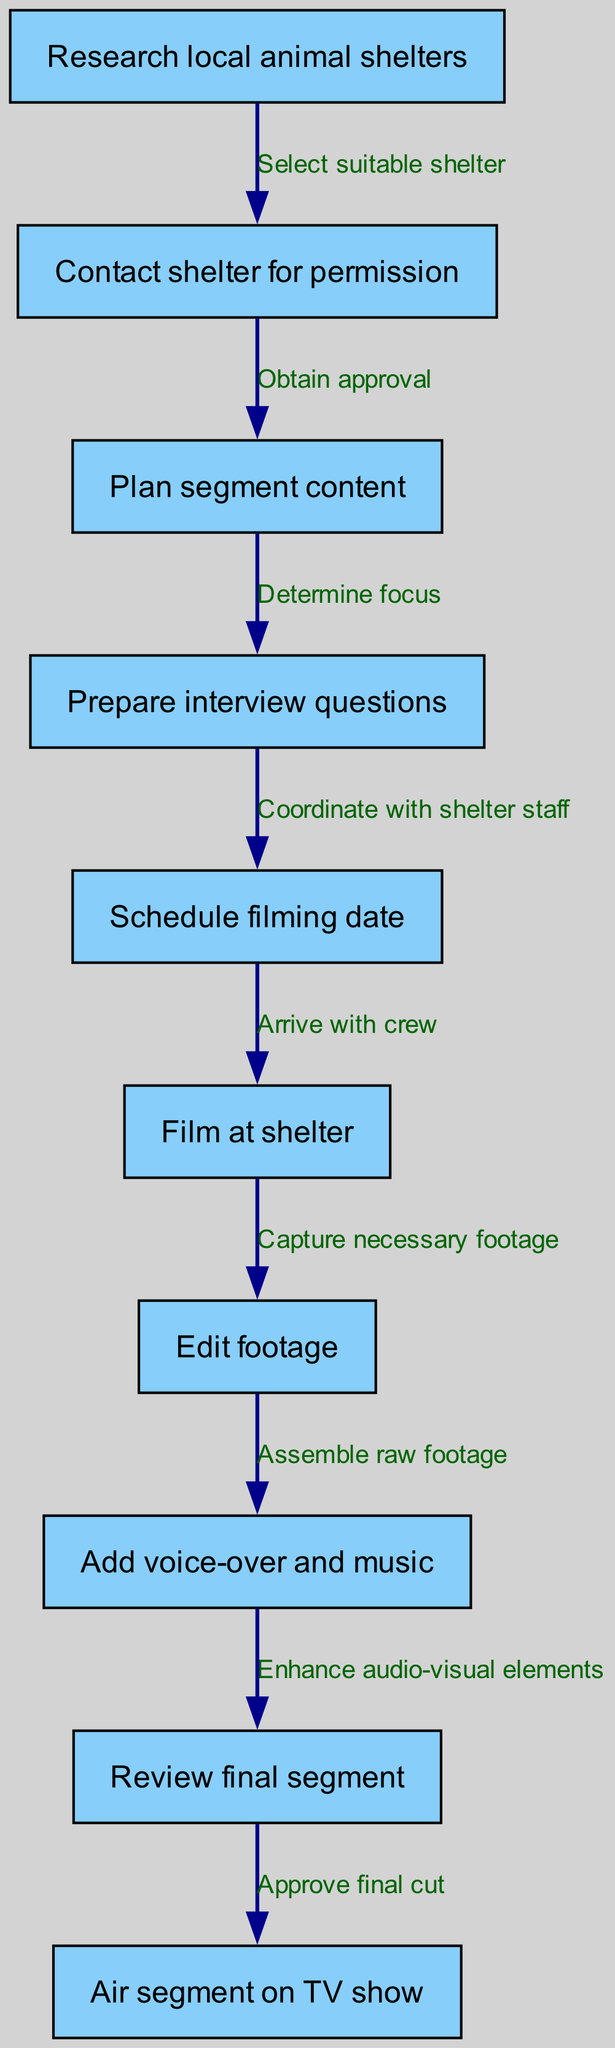What is the first step in the diagram? The diagram starts with "Research local animal shelters," indicating that this is the initial action necessary before proceeding with the segment production.
Answer: Research local animal shelters How many nodes are present in the diagram? There are a total of ten nodes listed in the diagram, each representing a distinct step in the shelter segment production process.
Answer: 10 What step follows "Contact shelter for permission"? After "Contact shelter for permission," the next step is "Plan segment content," indicating the progression from gaining permission to planning what will be included in the segment.
Answer: Plan segment content What is the last step in the process depicted in the diagram? The final step shown in the diagram is "Air segment on TV show," which represents the conclusion of all preceding activities and the actual broadcasting of the segment.
Answer: Air segment on TV show Which step involves the creation of interview questions? The step that involves creating interview questions is "Prepare interview questions," and it follows the planning of the segment's content.
Answer: Prepare interview questions What is the relationship between "Edit footage" and "Add voice-over and music"? The relationship is sequential; after "Edit footage" is completed, the next action is "Add voice-over and music," indicating that editing comes before enhancing the audio-visual elements.
Answer: Enhance audio-visual elements What is required before scheduling the filming date? Before scheduling the filming date, it is necessary to "Prepare interview questions," which ensures that the filming is well-prepared in advance.
Answer: Prepare interview questions How does one obtain approval to plan segment content? One obtains approval to plan segment content by "Contacting the shelter for permission," illustrating the dependence of content planning on securing the shelter's consent.
Answer: Contact shelter for permission 